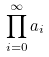Convert formula to latex. <formula><loc_0><loc_0><loc_500><loc_500>\prod _ { i = 0 } ^ { \infty } a _ { i }</formula> 